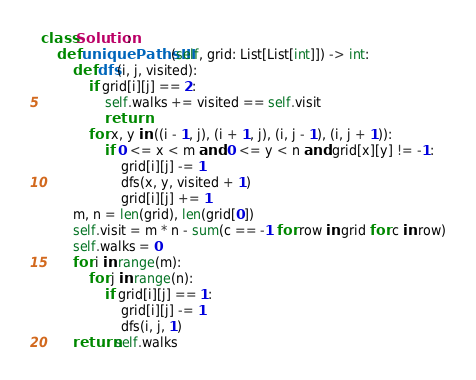<code> <loc_0><loc_0><loc_500><loc_500><_Python_>class Solution:
    def uniquePathsIII(self, grid: List[List[int]]) -> int:
        def dfs(i, j, visited):
            if grid[i][j] == 2:
                self.walks += visited == self.visit
                return
            for x, y in ((i - 1, j), (i + 1, j), (i, j - 1), (i, j + 1)):
                if 0 <= x < m and 0 <= y < n and grid[x][y] != -1:
                    grid[i][j] -= 1
                    dfs(x, y, visited + 1)
                    grid[i][j] += 1
        m, n = len(grid), len(grid[0])
        self.visit = m * n - sum(c == -1 for row in grid for c in row)
        self.walks = 0
        for i in range(m):
            for j in range(n):
                if grid[i][j] == 1:
                    grid[i][j] -= 1
                    dfs(i, j, 1)
        return self.walks</code> 